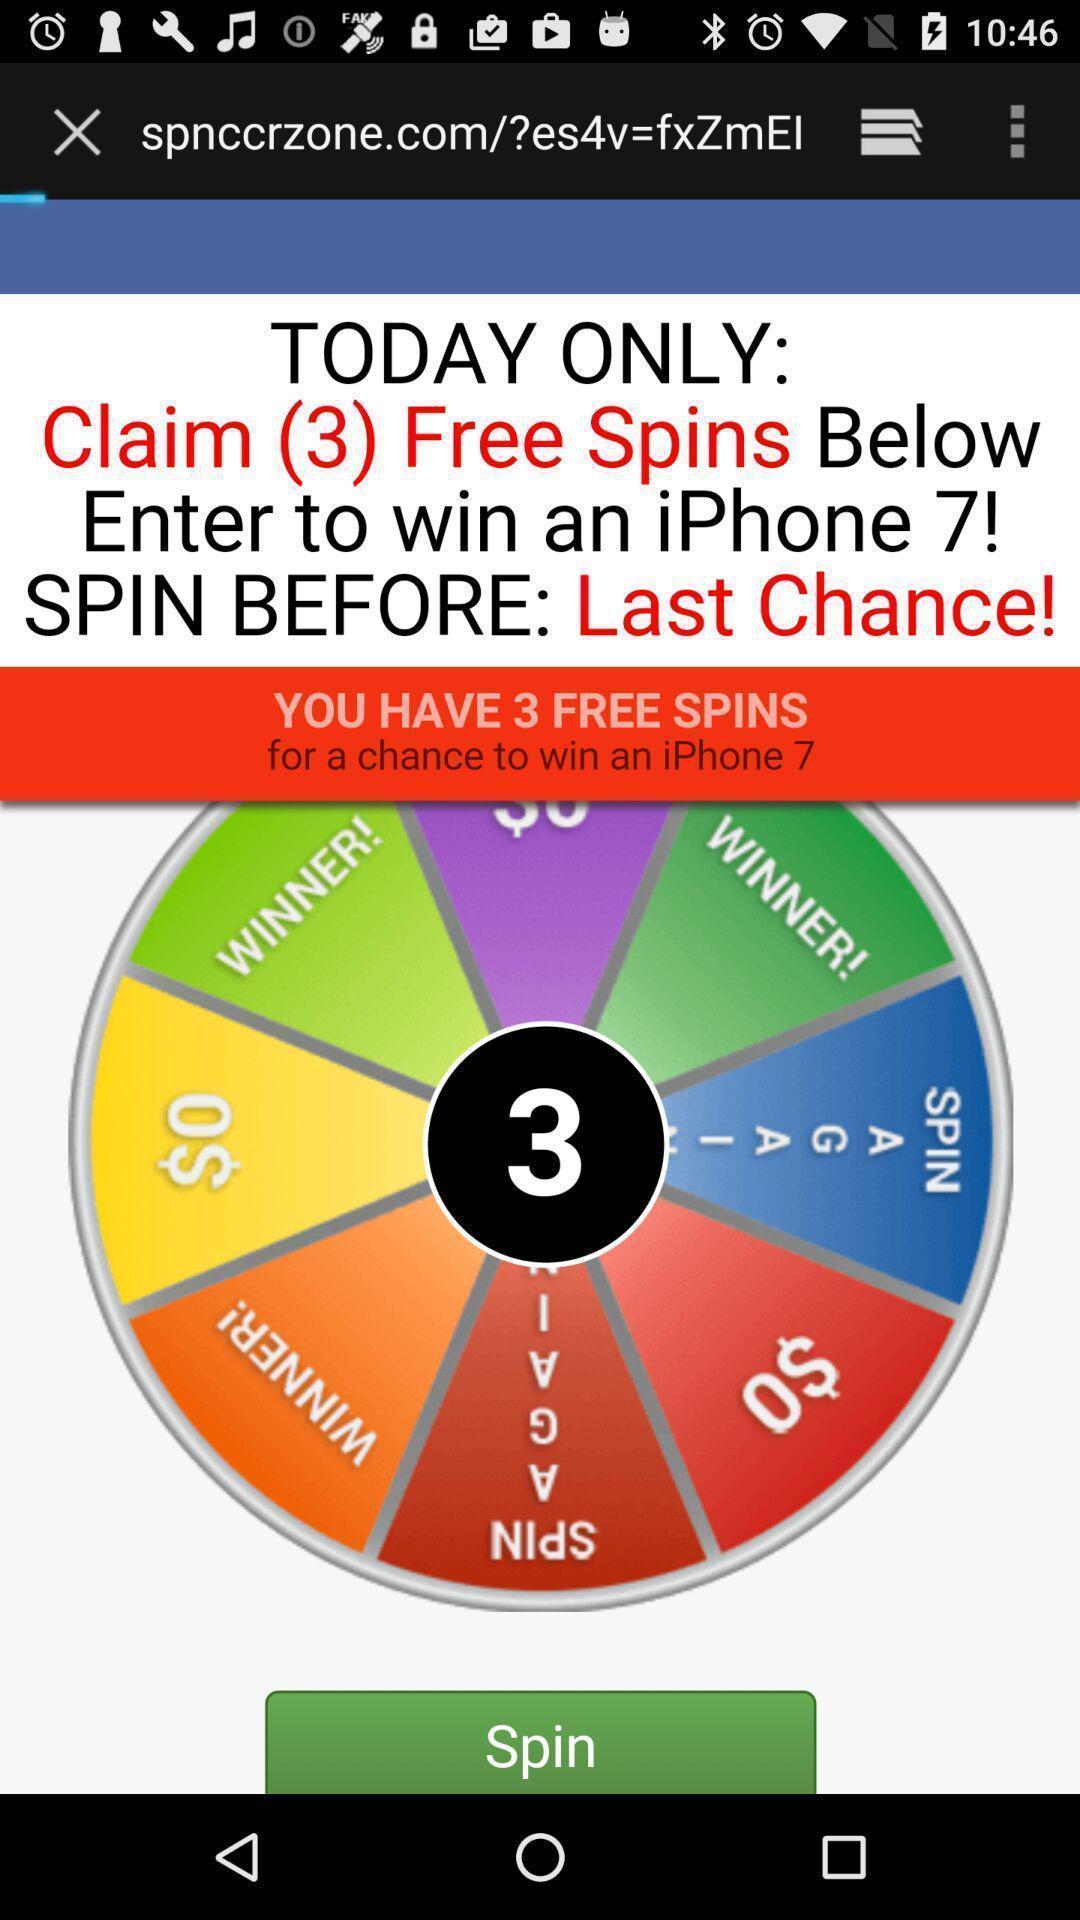Provide a detailed account of this screenshot. Window displaying a page to win prizes. 